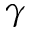Convert formula to latex. <formula><loc_0><loc_0><loc_500><loc_500>\gamma</formula> 